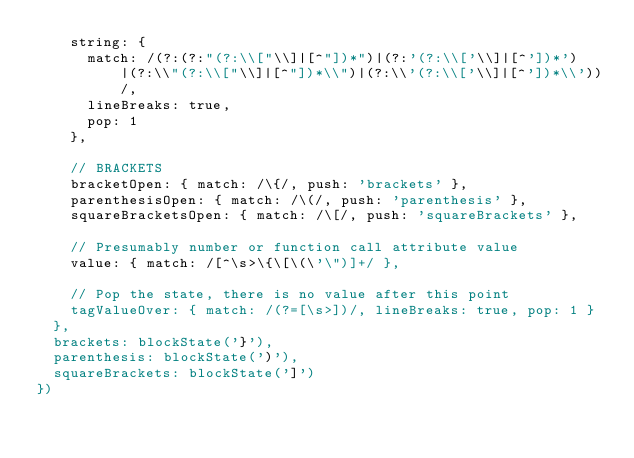<code> <loc_0><loc_0><loc_500><loc_500><_TypeScript_>    string: {
      match: /(?:(?:"(?:\\["\\]|[^"])*")|(?:'(?:\\['\\]|[^'])*')|(?:\\"(?:\\["\\]|[^"])*\\")|(?:\\'(?:\\['\\]|[^'])*\\'))/,
      lineBreaks: true,
      pop: 1
    },

    // BRACKETS
    bracketOpen: { match: /\{/, push: 'brackets' },
    parenthesisOpen: { match: /\(/, push: 'parenthesis' },
    squareBracketsOpen: { match: /\[/, push: 'squareBrackets' },

    // Presumably number or function call attribute value
    value: { match: /[^\s>\{\[\(\'\")]+/ },

    // Pop the state, there is no value after this point
    tagValueOver: { match: /(?=[\s>])/, lineBreaks: true, pop: 1 }
  },
  brackets: blockState('}'),
  parenthesis: blockState(')'),
  squareBrackets: blockState(']')
})
</code> 